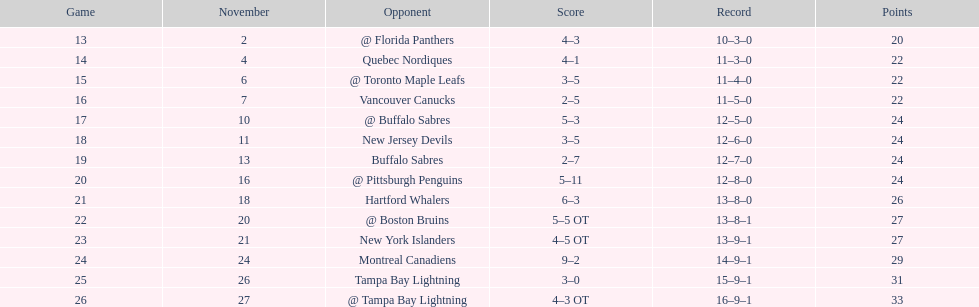Did the tampa bay lightning record the fewest victories? Yes. 